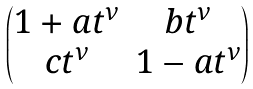Convert formula to latex. <formula><loc_0><loc_0><loc_500><loc_500>\begin{pmatrix} 1 + a t ^ { \nu } & b t ^ { \nu } \\ c t ^ { \nu } & 1 - a t ^ { \nu } \end{pmatrix}</formula> 